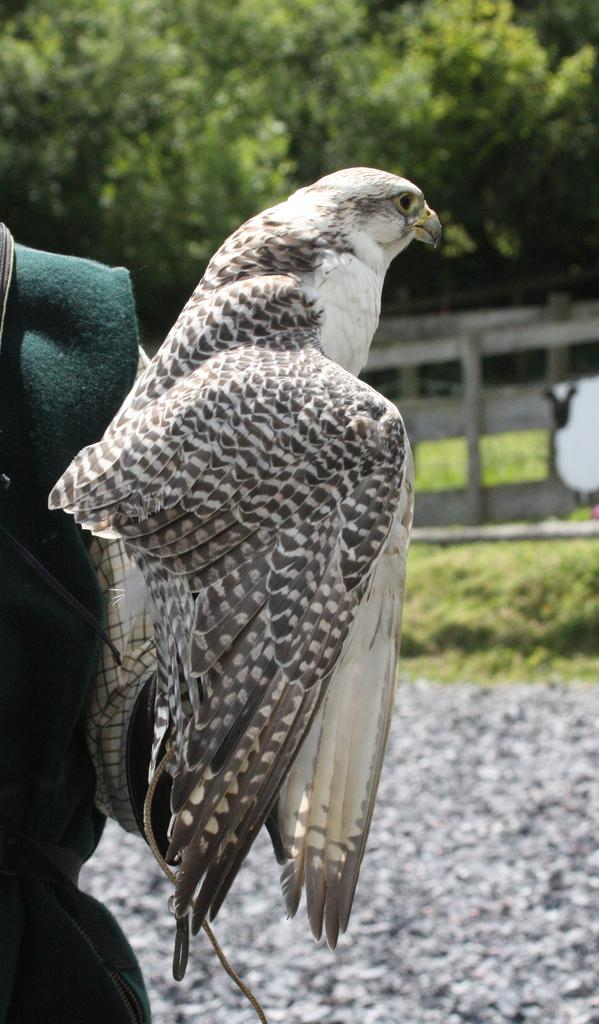What is the main subject of the image? There is a person in the image. What is the person doing in the image? The person is holding a bird in his hand. What can be seen in the background of the image? There are trees and a wooden fence in the background of the image. What type of crown is the person wearing in the image? There is no crown present in the image; the person is holding a bird in his hand. What observation can be made about the bird's behavior in the image? The image does not show the bird's behavior, as it only shows the person holding the bird in his hand. 